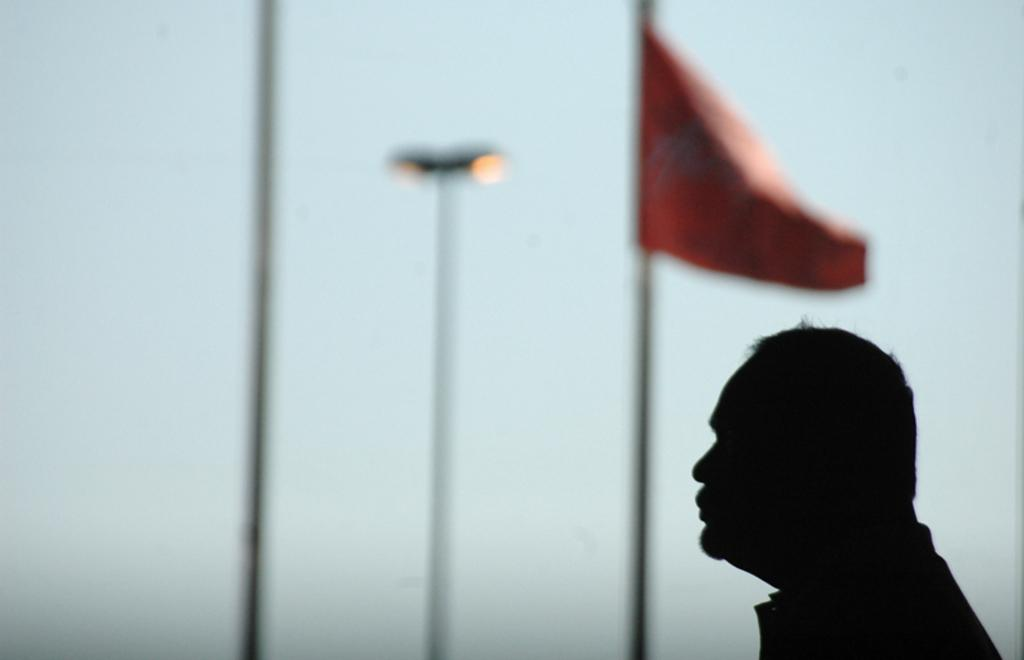Who or what is the main subject in the image? There is a person in the image. What is the person standing in front of? The person is standing in front of a flag. Can you describe the background of the person? The background of the person is blurred. What type of string is being played by the person in the image? There is no string or instrument present in the image; it only features a person standing in front of a flag. 